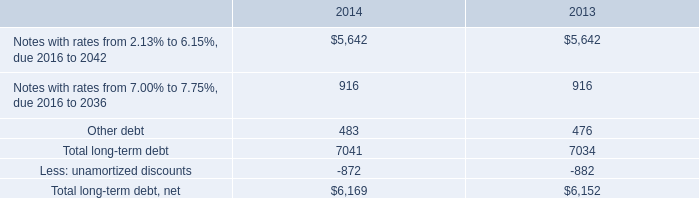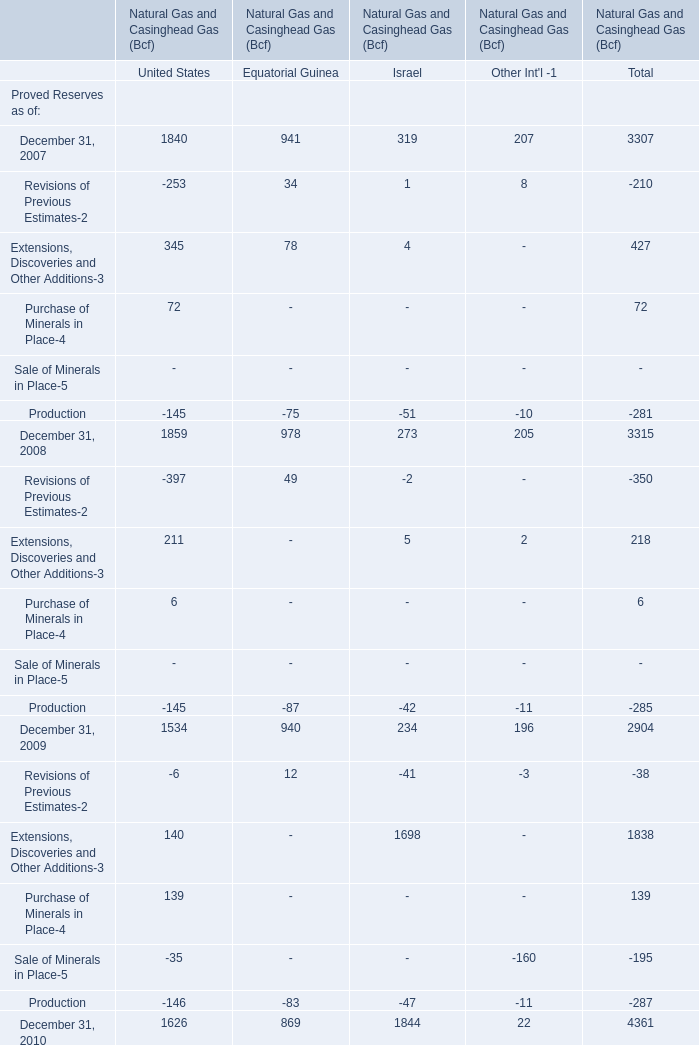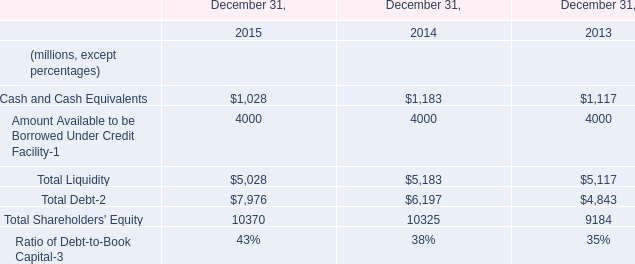What is the sum of Proved Reserves as of December 31, 2007, December 31, 2008 and December 31, 2009 for United States ? 
Computations: ((1840 + 1859) + 1534)
Answer: 5233.0. 